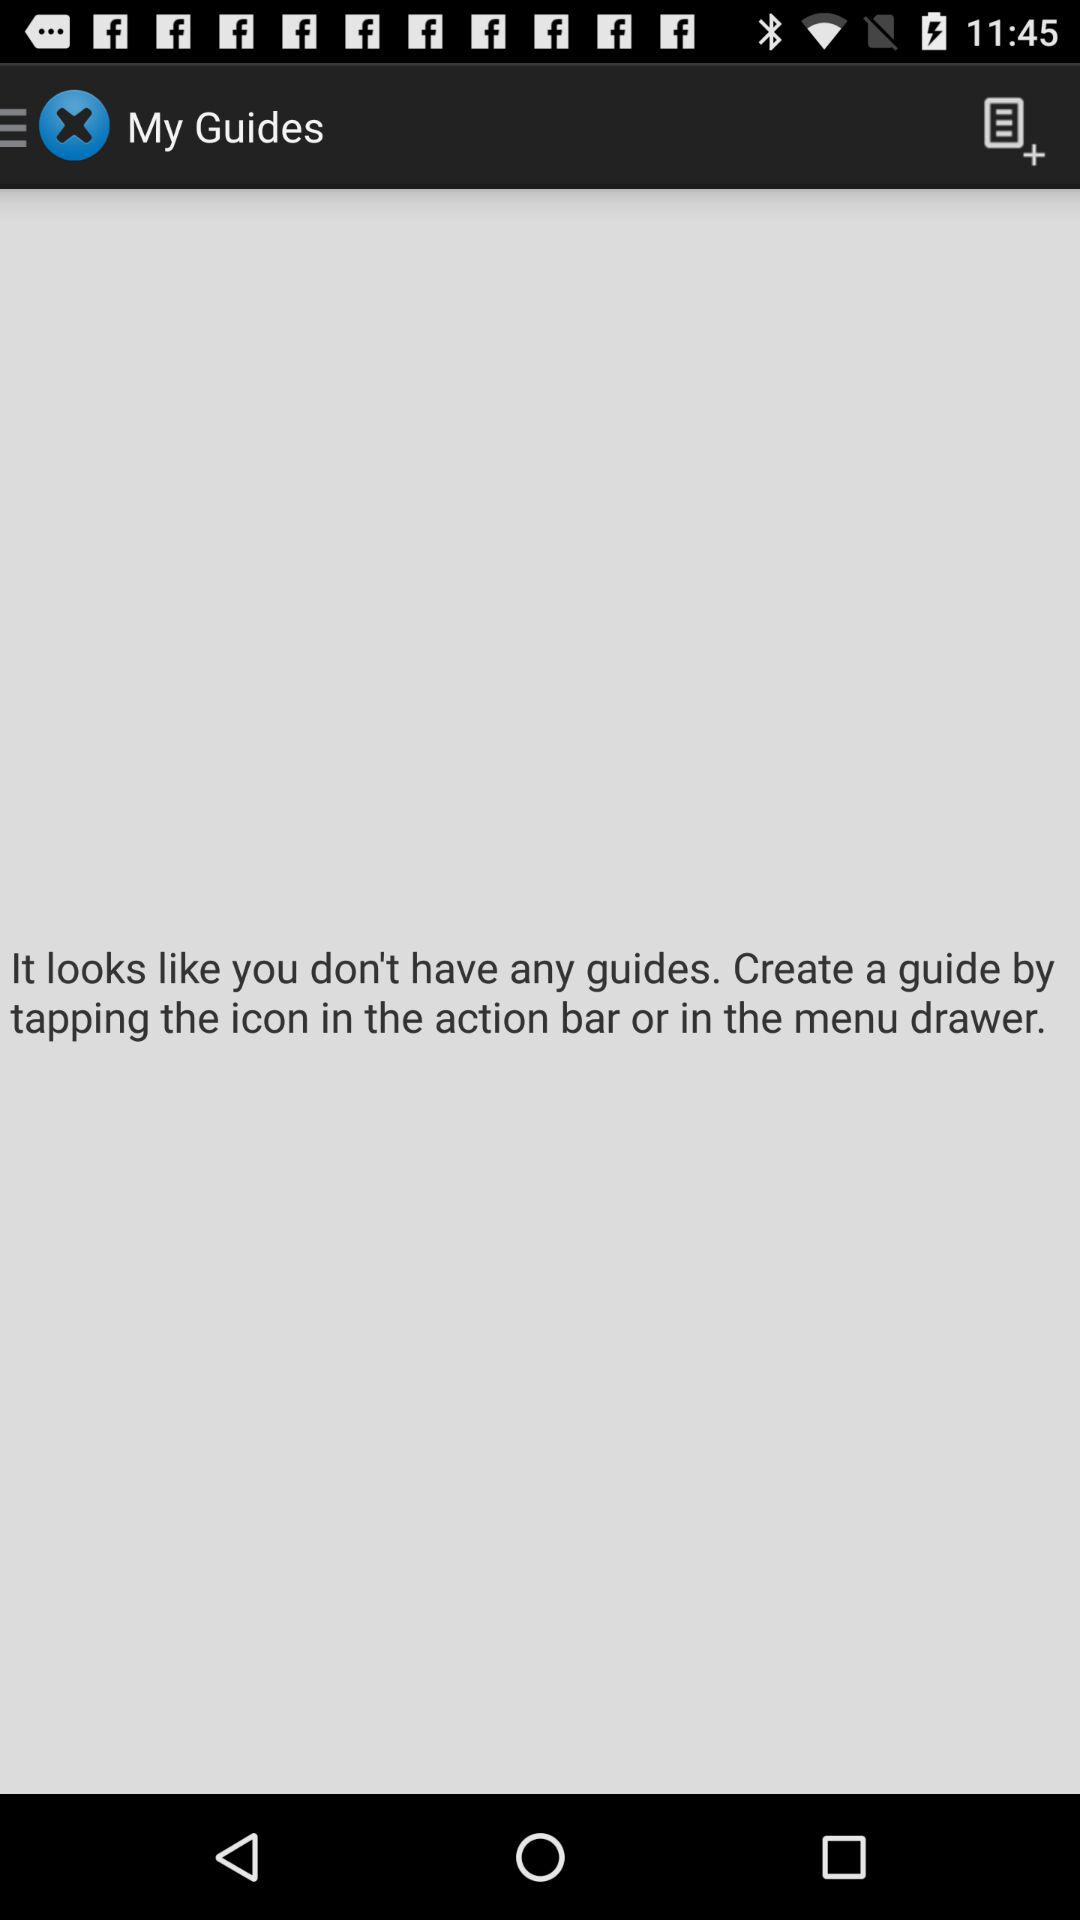How to create a guide? Create a guide "by tapping the icon in the action bar or in the menu drawer". 